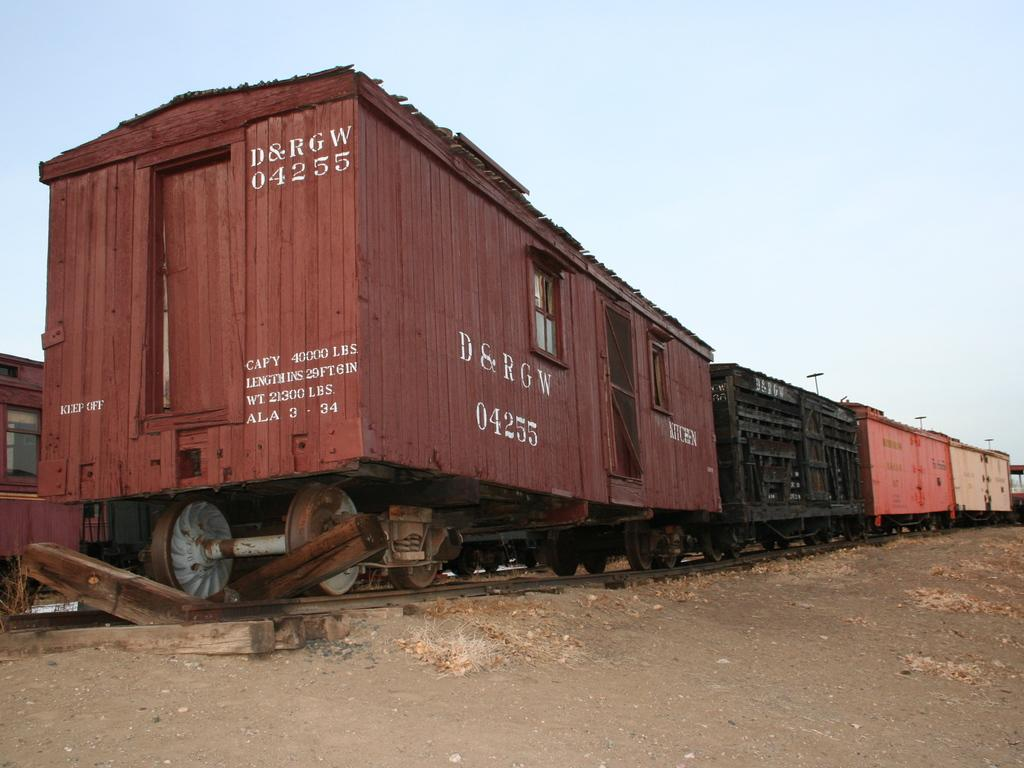<image>
Write a terse but informative summary of the picture. An old train car from D&RGW sits in a dirt field. 